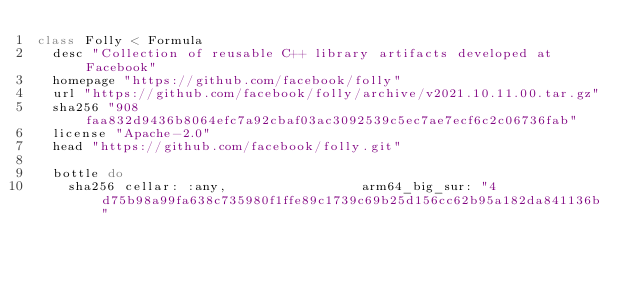<code> <loc_0><loc_0><loc_500><loc_500><_Ruby_>class Folly < Formula
  desc "Collection of reusable C++ library artifacts developed at Facebook"
  homepage "https://github.com/facebook/folly"
  url "https://github.com/facebook/folly/archive/v2021.10.11.00.tar.gz"
  sha256 "908faa832d9436b8064efc7a92cbaf03ac3092539c5ec7ae7ecf6c2c06736fab"
  license "Apache-2.0"
  head "https://github.com/facebook/folly.git"

  bottle do
    sha256 cellar: :any,                 arm64_big_sur: "4d75b98a99fa638c735980f1ffe89c1739c69b25d156cc62b95a182da841136b"</code> 